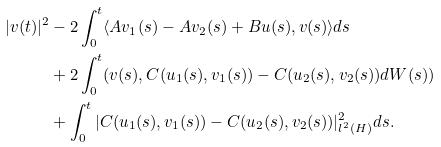<formula> <loc_0><loc_0><loc_500><loc_500>| v ( t ) | ^ { 2 } & - 2 \int _ { 0 } ^ { t } \langle A v _ { 1 } ( s ) - A v _ { 2 } ( s ) + B u ( s ) , v ( s ) \rangle d s \\ & + 2 \int _ { 0 } ^ { t } ( v ( s ) , C ( u _ { 1 } ( s ) , v _ { 1 } ( s ) ) - C ( u _ { 2 } ( s ) , v _ { 2 } ( s ) ) d W ( s ) ) \\ & + \int _ { 0 } ^ { t } | C ( u _ { 1 } ( s ) , v _ { 1 } ( s ) ) - C ( u _ { 2 } ( s ) , v _ { 2 } ( s ) ) | _ { l ^ { 2 } ( H ) } ^ { 2 } d s .</formula> 